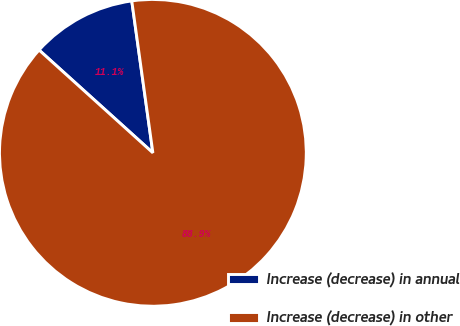Convert chart to OTSL. <chart><loc_0><loc_0><loc_500><loc_500><pie_chart><fcel>Increase (decrease) in annual<fcel>Increase (decrease) in other<nl><fcel>11.11%<fcel>88.89%<nl></chart> 